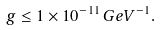<formula> <loc_0><loc_0><loc_500><loc_500>g \leq 1 \times 1 0 ^ { - 1 1 } \, G e V ^ { - 1 } .</formula> 